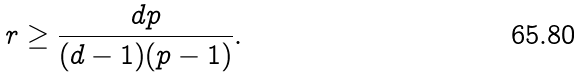<formula> <loc_0><loc_0><loc_500><loc_500>r \geq \frac { d p } { ( d - 1 ) ( p - 1 ) } .</formula> 